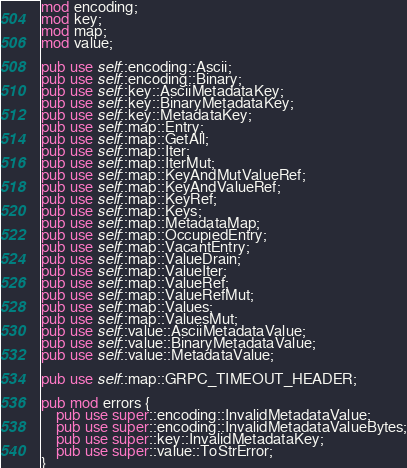Convert code to text. <code><loc_0><loc_0><loc_500><loc_500><_Rust_>mod encoding;
mod key;
mod map;
mod value;

pub use self::encoding::Ascii;
pub use self::encoding::Binary;
pub use self::key::AsciiMetadataKey;
pub use self::key::BinaryMetadataKey;
pub use self::key::MetadataKey;
pub use self::map::Entry;
pub use self::map::GetAll;
pub use self::map::Iter;
pub use self::map::IterMut;
pub use self::map::KeyAndMutValueRef;
pub use self::map::KeyAndValueRef;
pub use self::map::KeyRef;
pub use self::map::Keys;
pub use self::map::MetadataMap;
pub use self::map::OccupiedEntry;
pub use self::map::VacantEntry;
pub use self::map::ValueDrain;
pub use self::map::ValueIter;
pub use self::map::ValueRef;
pub use self::map::ValueRefMut;
pub use self::map::Values;
pub use self::map::ValuesMut;
pub use self::value::AsciiMetadataValue;
pub use self::value::BinaryMetadataValue;
pub use self::value::MetadataValue;

pub use self::map::GRPC_TIMEOUT_HEADER;

pub mod errors {
    pub use super::encoding::InvalidMetadataValue;
    pub use super::encoding::InvalidMetadataValueBytes;
    pub use super::key::InvalidMetadataKey;
    pub use super::value::ToStrError;
}
</code> 